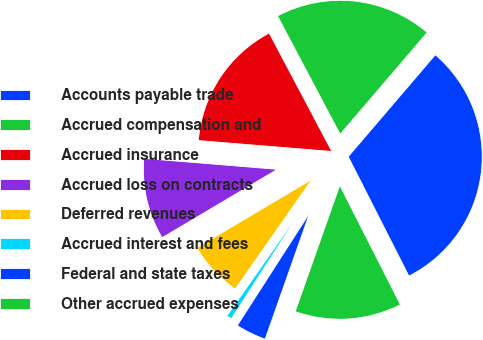<chart> <loc_0><loc_0><loc_500><loc_500><pie_chart><fcel>Accounts payable trade<fcel>Accrued compensation and<fcel>Accrued insurance<fcel>Accrued loss on contracts<fcel>Deferred revenues<fcel>Accrued interest and fees<fcel>Federal and state taxes<fcel>Other accrued expenses<nl><fcel>31.26%<fcel>19.01%<fcel>15.95%<fcel>9.82%<fcel>6.76%<fcel>0.63%<fcel>3.69%<fcel>12.88%<nl></chart> 